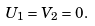Convert formula to latex. <formula><loc_0><loc_0><loc_500><loc_500>U _ { 1 } = V _ { 2 } = 0 .</formula> 